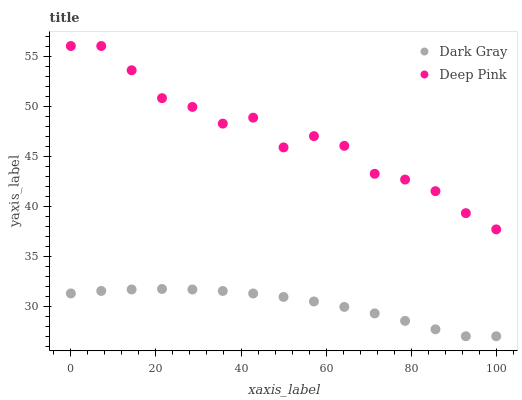Does Dark Gray have the minimum area under the curve?
Answer yes or no. Yes. Does Deep Pink have the maximum area under the curve?
Answer yes or no. Yes. Does Deep Pink have the minimum area under the curve?
Answer yes or no. No. Is Dark Gray the smoothest?
Answer yes or no. Yes. Is Deep Pink the roughest?
Answer yes or no. Yes. Is Deep Pink the smoothest?
Answer yes or no. No. Does Dark Gray have the lowest value?
Answer yes or no. Yes. Does Deep Pink have the lowest value?
Answer yes or no. No. Does Deep Pink have the highest value?
Answer yes or no. Yes. Is Dark Gray less than Deep Pink?
Answer yes or no. Yes. Is Deep Pink greater than Dark Gray?
Answer yes or no. Yes. Does Dark Gray intersect Deep Pink?
Answer yes or no. No. 